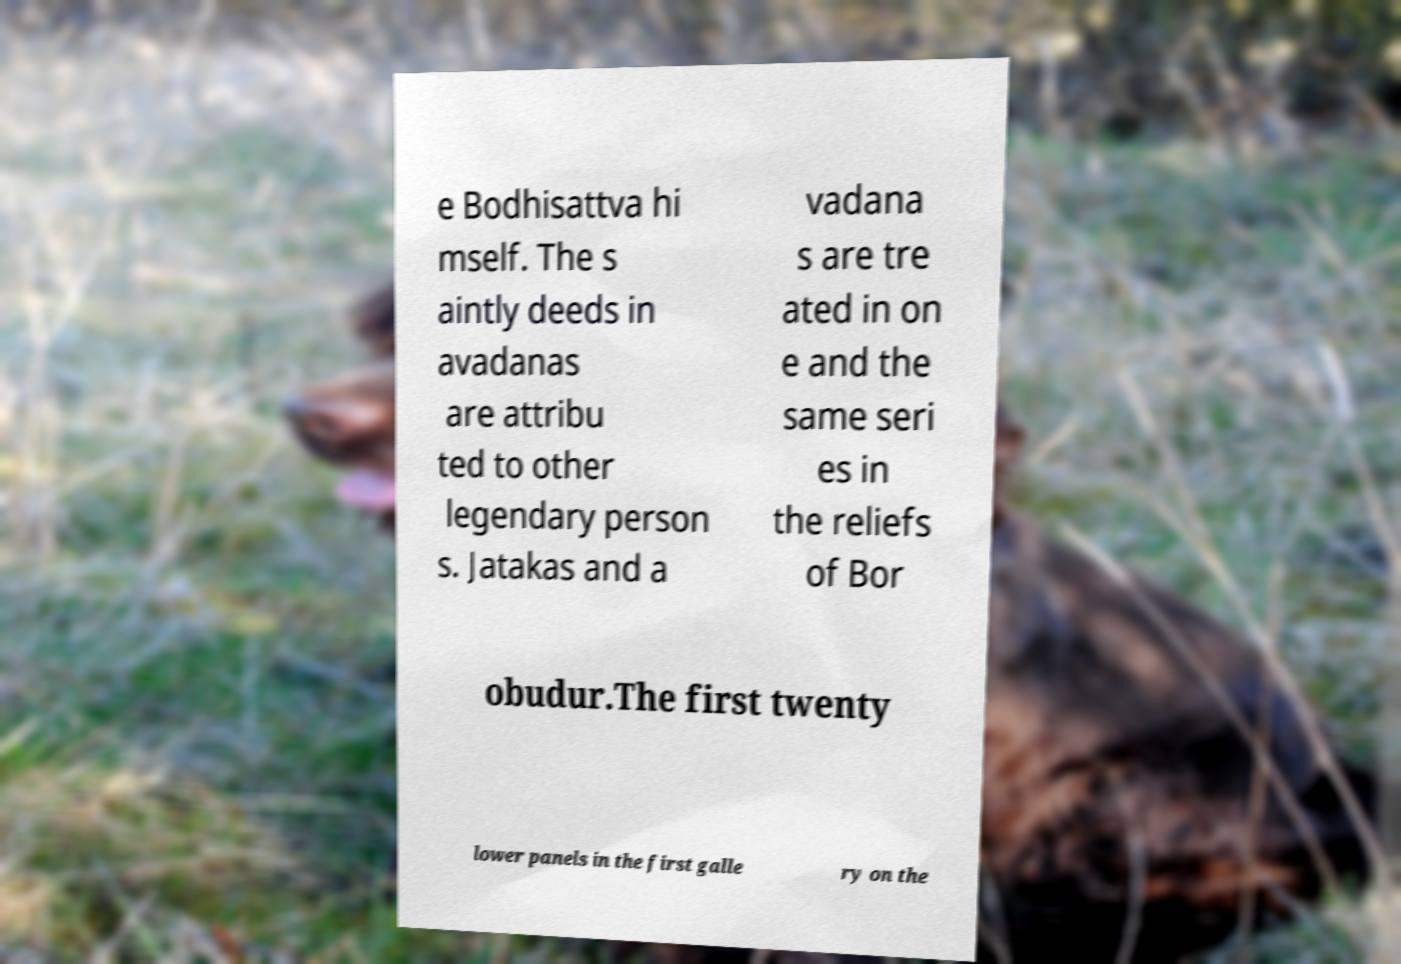Could you assist in decoding the text presented in this image and type it out clearly? e Bodhisattva hi mself. The s aintly deeds in avadanas are attribu ted to other legendary person s. Jatakas and a vadana s are tre ated in on e and the same seri es in the reliefs of Bor obudur.The first twenty lower panels in the first galle ry on the 